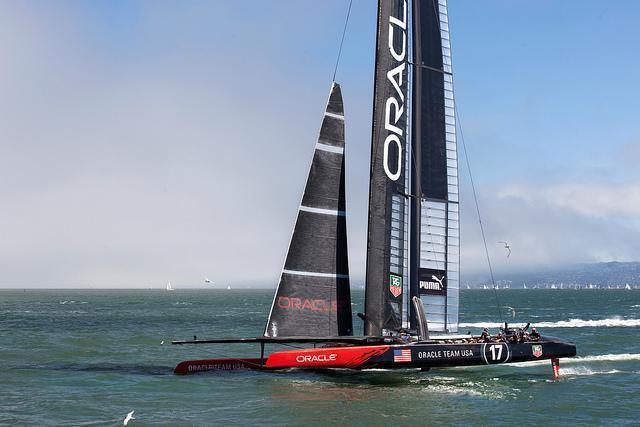How many boats are there?
Give a very brief answer. 1. 